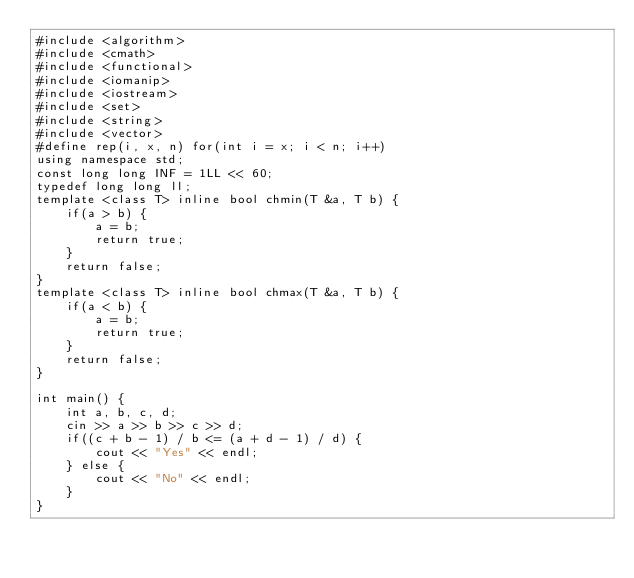<code> <loc_0><loc_0><loc_500><loc_500><_C++_>#include <algorithm>
#include <cmath>
#include <functional>
#include <iomanip>
#include <iostream>
#include <set>
#include <string>
#include <vector>
#define rep(i, x, n) for(int i = x; i < n; i++)
using namespace std;
const long long INF = 1LL << 60;
typedef long long ll;
template <class T> inline bool chmin(T &a, T b) {
    if(a > b) {
        a = b;
        return true;
    }
    return false;
}
template <class T> inline bool chmax(T &a, T b) {
    if(a < b) {
        a = b;
        return true;
    }
    return false;
}

int main() {
    int a, b, c, d;
    cin >> a >> b >> c >> d;
    if((c + b - 1) / b <= (a + d - 1) / d) {
        cout << "Yes" << endl;
    } else {
        cout << "No" << endl;
    }
}</code> 